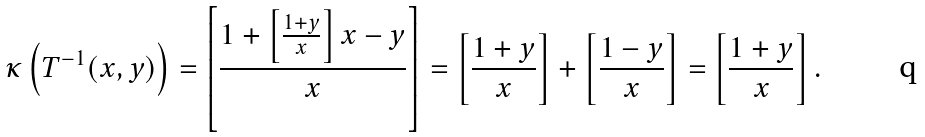<formula> <loc_0><loc_0><loc_500><loc_500>\kappa \left ( T ^ { - 1 } ( x , y ) \right ) = \left [ \frac { 1 + \left [ \frac { 1 + y } { x } \right ] x - y } { x } \right ] = \left [ \frac { 1 + y } { x } \right ] + \left [ \frac { 1 - y } { x } \right ] = \left [ \frac { 1 + y } { x } \right ] .</formula> 